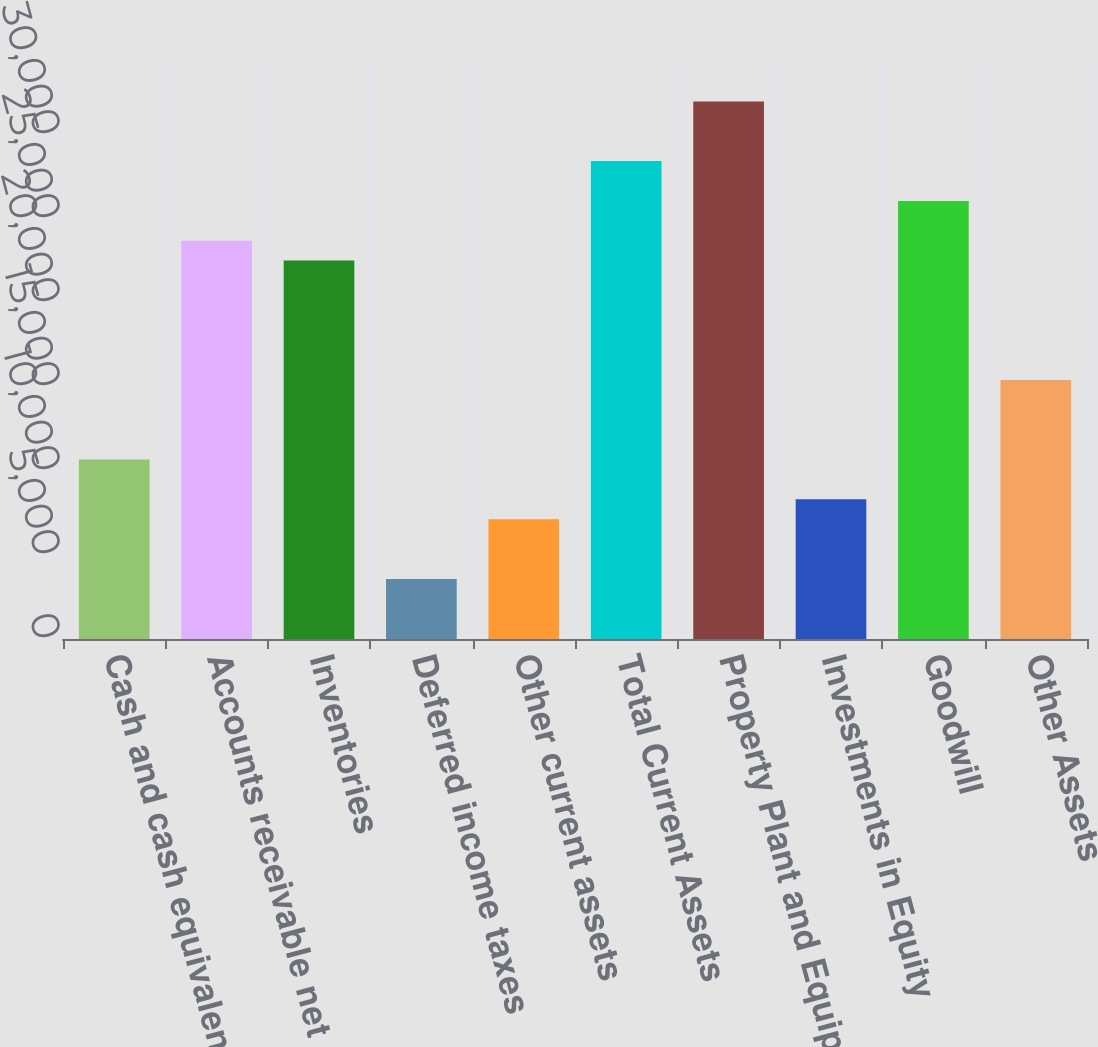Convert chart to OTSL. <chart><loc_0><loc_0><loc_500><loc_500><bar_chart><fcel>Cash and cash equivalents<fcel>Accounts receivable net<fcel>Inventories<fcel>Deferred income taxes<fcel>Other current assets<fcel>Total Current Assets<fcel>Property Plant and Equipment<fcel>Investments in Equity<fcel>Goodwill<fcel>Other Assets<nl><fcel>10681.5<fcel>23709.5<fcel>22525.1<fcel>3575.38<fcel>7128.46<fcel>28446.9<fcel>32000<fcel>8312.82<fcel>26078.2<fcel>15419<nl></chart> 